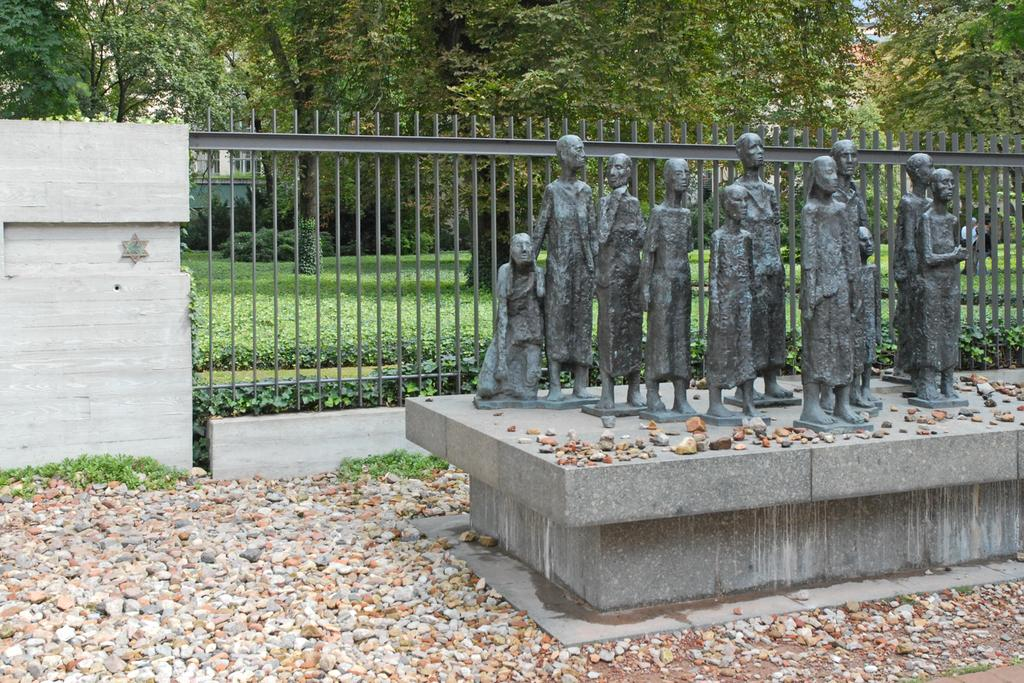What can be seen on the path in the image? There are statues on the path in the image. What is located on the left side of the statues? There are stones on the left side of the statues. What is behind the statues? There is a fence, plants, and trees behind the statues. What is visible in the background of the image? The sky and walls are visible in the background of the image. What type of spoon is being used to stitch the weight in the image? There is no spoon, stitching, or weight present in the image. 